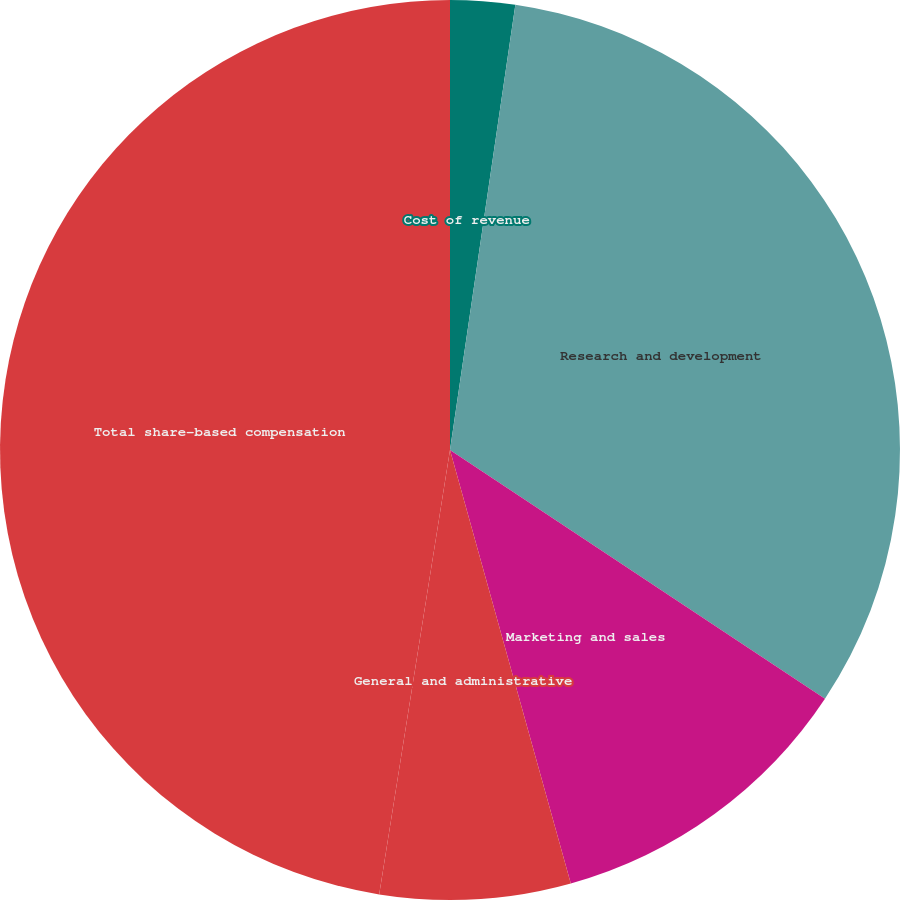<chart> <loc_0><loc_0><loc_500><loc_500><pie_chart><fcel>Cost of revenue<fcel>Research and development<fcel>Marketing and sales<fcel>General and administrative<fcel>Total share-based compensation<nl><fcel>2.32%<fcel>32.0%<fcel>11.35%<fcel>6.84%<fcel>47.48%<nl></chart> 